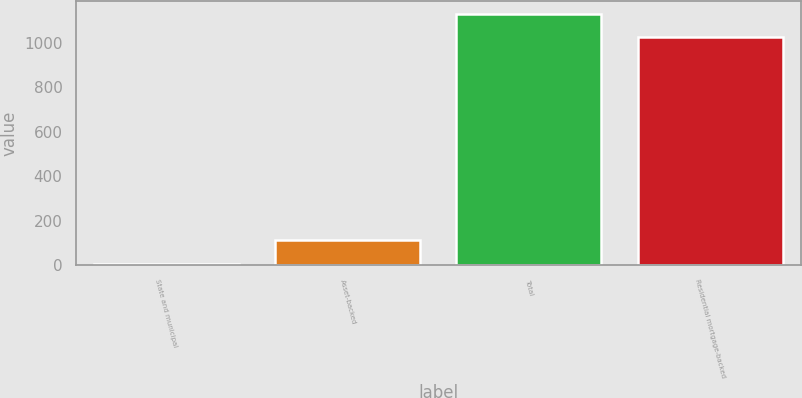Convert chart to OTSL. <chart><loc_0><loc_0><loc_500><loc_500><bar_chart><fcel>State and municipal<fcel>Asset-backed<fcel>Total<fcel>Residential mortgage-backed<nl><fcel>8<fcel>114<fcel>1130.7<fcel>1026<nl></chart> 